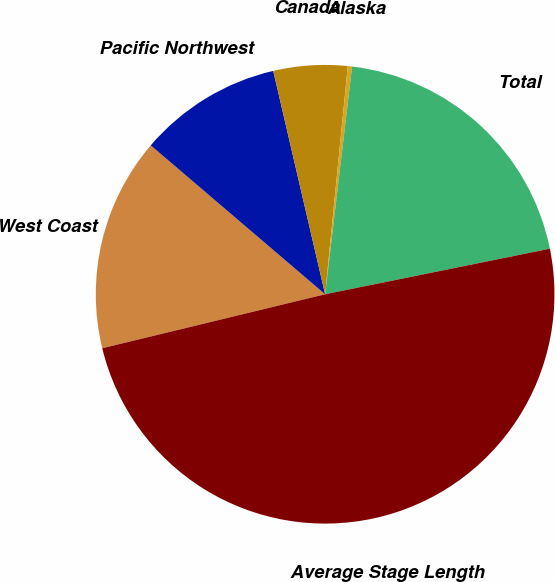Convert chart. <chart><loc_0><loc_0><loc_500><loc_500><pie_chart><fcel>West Coast<fcel>Pacific Northwest<fcel>Canada<fcel>Alaska<fcel>Total<fcel>Average Stage Length<nl><fcel>15.03%<fcel>10.12%<fcel>5.21%<fcel>0.3%<fcel>19.94%<fcel>49.4%<nl></chart> 